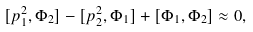<formula> <loc_0><loc_0><loc_500><loc_500>[ p _ { 1 } ^ { 2 } , \Phi _ { 2 } ] - [ p _ { 2 } ^ { 2 } , \Phi _ { 1 } ] + [ \Phi _ { 1 } , \Phi _ { 2 } ] \approx 0 ,</formula> 